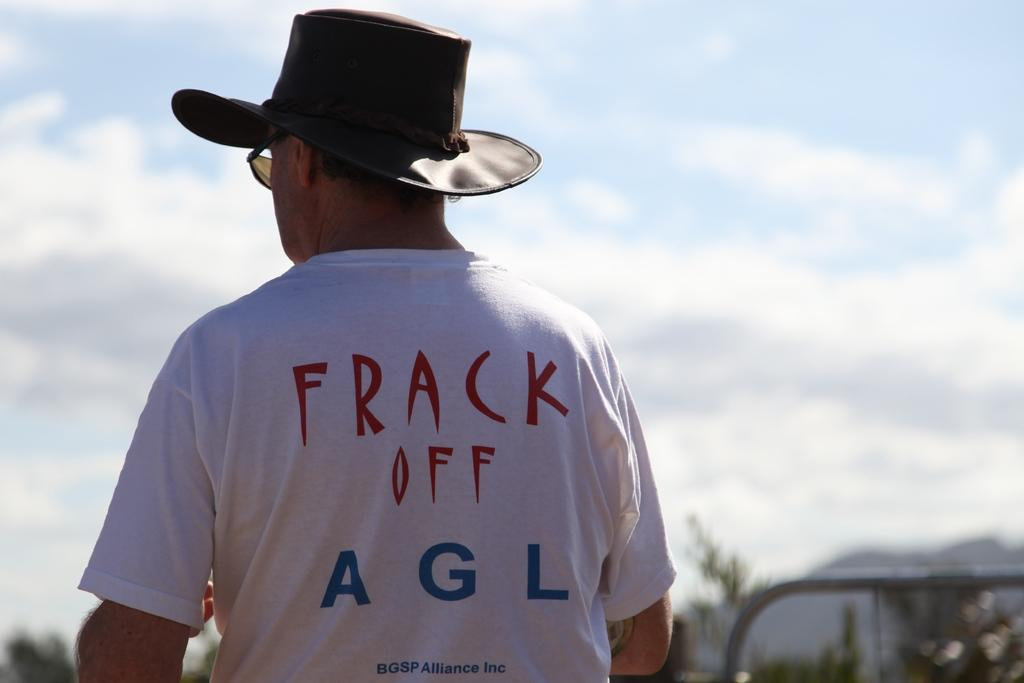<image>
Offer a succinct explanation of the picture presented. A guy is in a shirt with the words frack off on the back. 